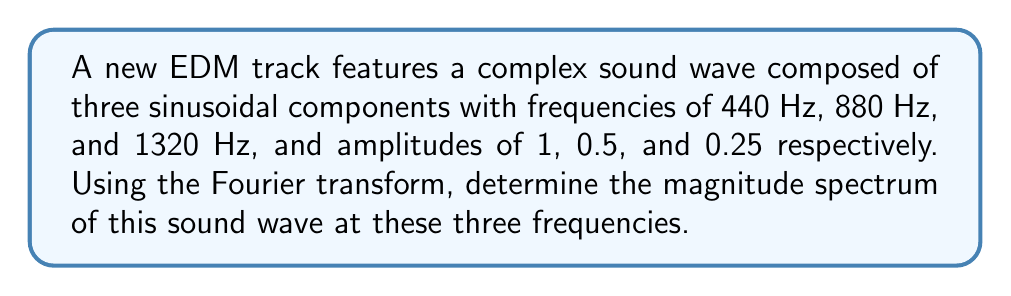Provide a solution to this math problem. To analyze the frequency spectrum of this complex sound wave using Fourier transforms, we'll follow these steps:

1) The complex sound wave can be represented as a sum of sinusoidal components:

   $$x(t) = 1 \cdot \sin(2\pi \cdot 440t) + 0.5 \cdot \sin(2\pi \cdot 880t) + 0.25 \cdot \sin(2\pi \cdot 1320t)$$

2) The Fourier transform of a sinusoidal function $A \cdot \sin(2\pi ft)$ is given by:

   $$X(f) = \frac{A}{2i}[\delta(f-f_0) - \delta(f+f_0)]$$

   where $\delta$ is the Dirac delta function, $A$ is the amplitude, and $f_0$ is the frequency.

3) Applying this to each component:

   For 440 Hz: $$X_1(f) = \frac{1}{2i}[\delta(f-440) - \delta(f+440)]$$
   For 880 Hz: $$X_2(f) = \frac{0.5}{2i}[\delta(f-880) - \delta(f+880)]$$
   For 1320 Hz: $$X_3(f) = \frac{0.25}{2i}[\delta(f-1320) - \delta(f+1320)]$$

4) The total Fourier transform is the sum of these components:

   $$X(f) = X_1(f) + X_2(f) + X_3(f)$$

5) The magnitude spectrum is given by the absolute value of $X(f)$. At each frequency:

   At 440 Hz: $|X(440)| = |\frac{1}{2i}| = 0.5$
   At 880 Hz: $|X(880)| = |\frac{0.5}{2i}| = 0.25$
   At 1320 Hz: $|X(1320)| = |\frac{0.25}{2i}| = 0.125$

Therefore, the magnitude spectrum at these three frequencies is [0.5, 0.25, 0.125].
Answer: [0.5, 0.25, 0.125] 